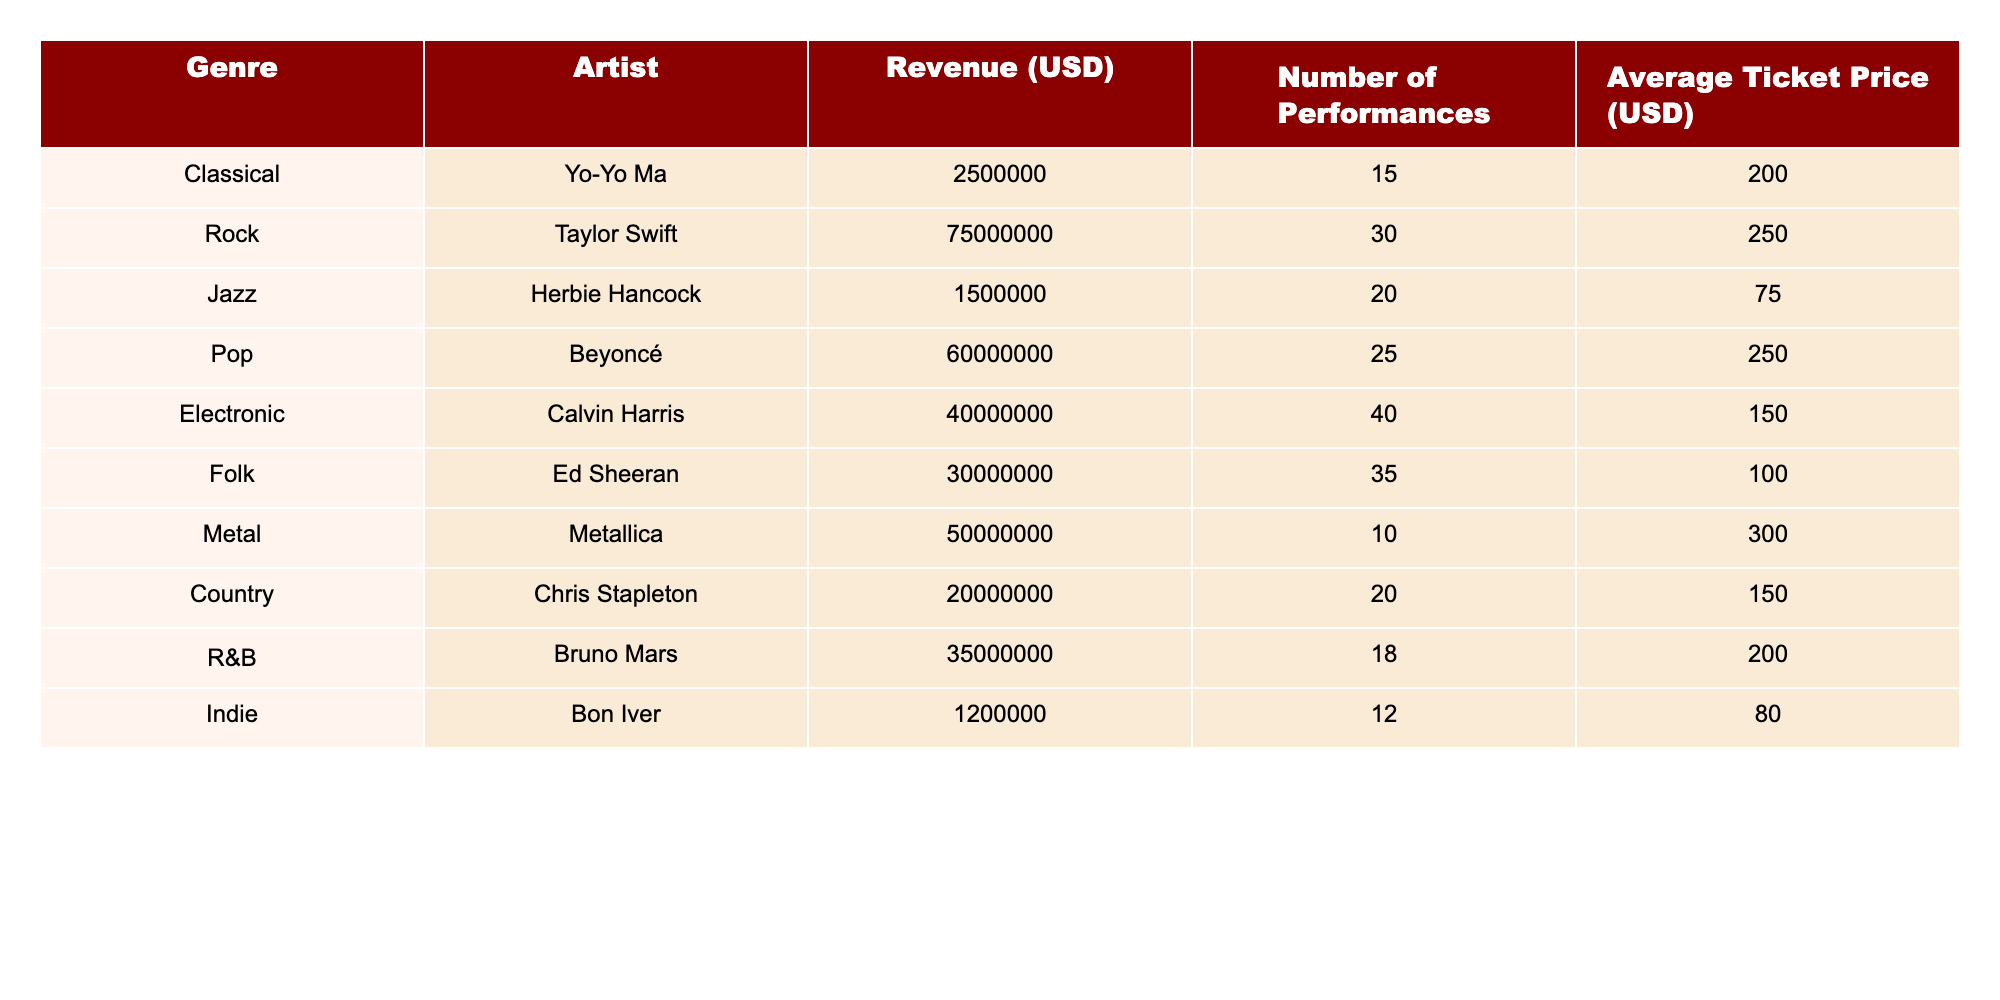What is the total revenue generated from live performances in 2023? To find the total revenue, we sum the revenue of each genre: (2500000 + 75000000 + 1500000 + 60000000 + 40000000 + 30000000 + 50000000 + 20000000 + 35000000 + 1200000) = 189200000.
Answer: 189200000 Which genre had the highest average ticket price? By comparing the average ticket prices, we notice Metal had the highest average ticket price at 300 USD.
Answer: Metal How much revenue did the folk genre generate? The revenue from the folk genre is listed as 30000000 USD directly in the table.
Answer: 30000000 What percentage of the total revenue is generated by the pop genre? The revenue from pop is 60000000 USD. Calculating its percentage of total revenue: (60000000 / 189200000) * 100 ≈ 31.7%.
Answer: 31.7% How many performances did the artist with the lowest revenue conduct? The artist with the lowest revenue is Bon Iver, and they conducted 12 performances.
Answer: 12 Is the average ticket price for jazz performances higher than for country performances? The average ticket price for jazz is 75 USD, while for country it is 150 USD. Therefore, jazz's price is lower than country’s.
Answer: No What is the total revenue generated by Rock and Pop genres together? To find this, we add the revenues from Rock (75000000) and Pop (60000000): 75000000 + 60000000 = 135000000.
Answer: 135000000 What genre has the least number of performances? By comparing the number of performances, we see that Metallica had the least with 10 performances.
Answer: Metal Which artist generated the most revenue from live performances? Taylor Swift generated the most revenue, totaling 75000000 USD.
Answer: Taylor Swift If the average ticket price for classical performances was increased to 250 USD, what would be the new revenue for classical genre? The new revenue would be calculated by multiplying the number of performances (15) by the new average ticket price (250): 15 * 250 = 3750, and multiplying that by the number of performances (15): 3750 * 15 = 56250.
Answer: 56250 